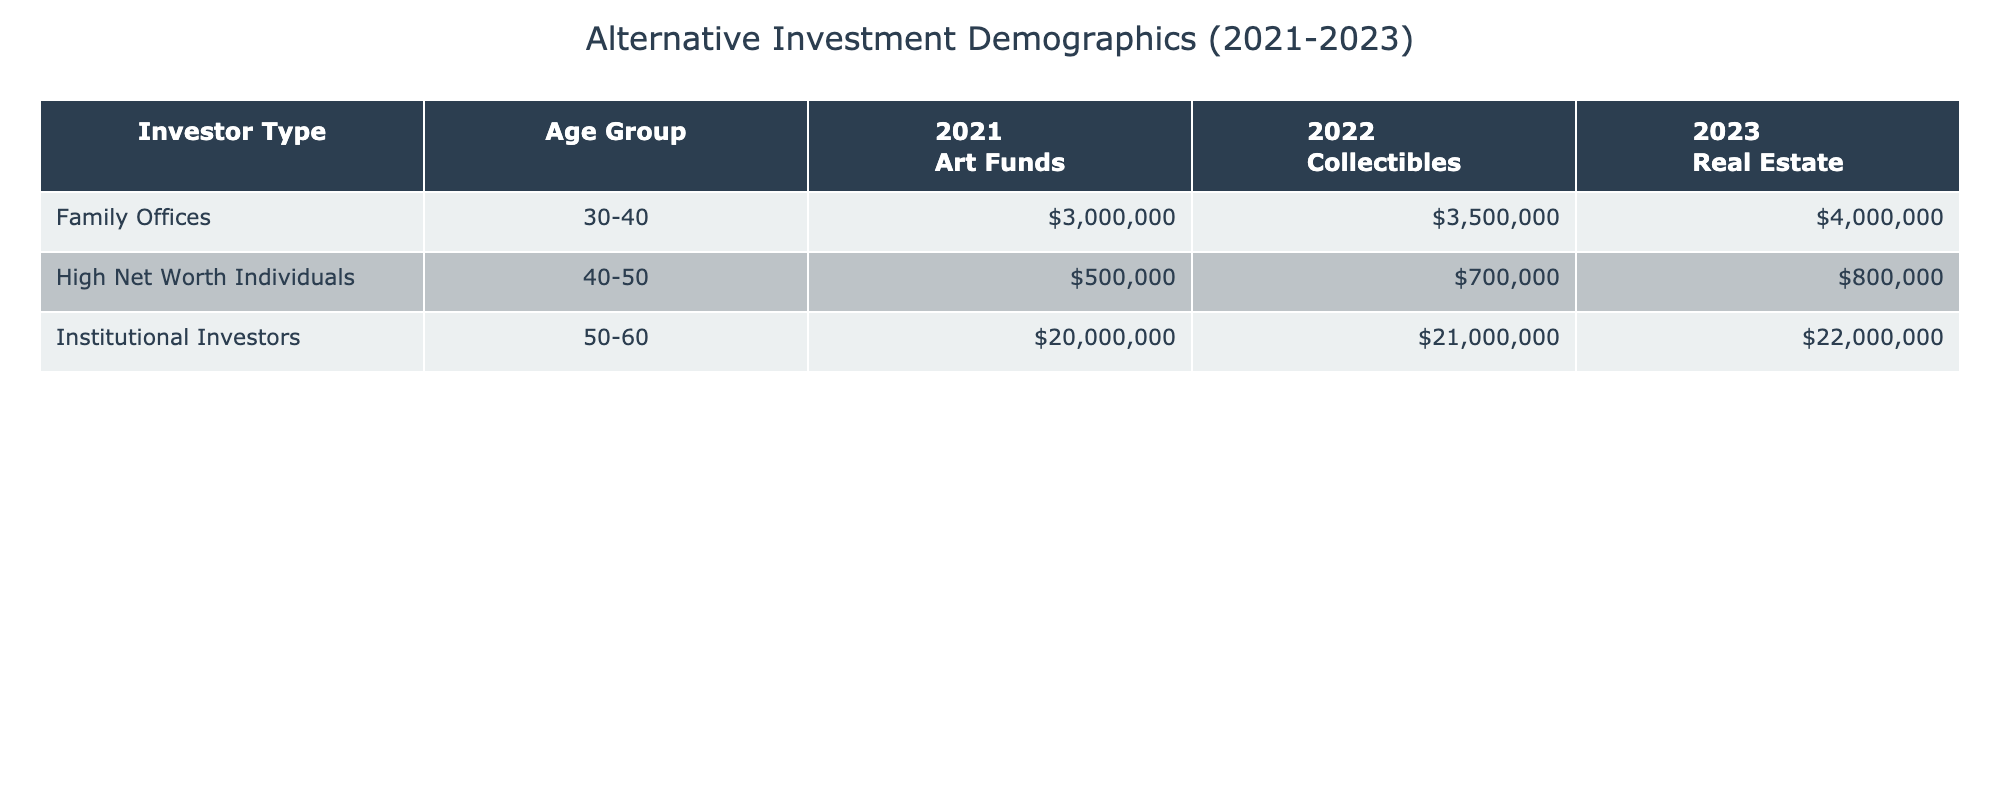What was the average investment of High Net Worth Individuals in Art Funds in 2021? The table shows that for High Net Worth Individuals in 2021, the average investment in Art Funds was $500,000.
Answer: $500,000 Which investor type had the highest average investment in 2023? In 2023, Institutional Investors had the highest average investment at $22,000,000, while High Net Worth Individuals and Family Offices had lower amounts for their respective investments.
Answer: Institutional Investors What is the average investment for Family Offices across all three years? To find the average: In 2021, they invested $3,000,000; in 2022, $3,500,000; and in 2023, $4,000,000. The total is $3,000,000 + $3,500,000 + $4,000,000 = $10,500,000. Dividing by 3 gives an average of $3,500,000.
Answer: $3,500,000 Did High Net Worth Individuals invest in collectibles in 2021? According to the table, High Net Worth Individuals did not invest in collectibles in 2021, as their recorded investment was in Art Funds.
Answer: No Which year saw a consistent increase in average investment for Institutional Investors from Art Funds to Real Estate? The averages for Institutional Investors in Art Funds in 2021, Collectibles in 2022, and Real Estate in 2023 are $20,000,000, $21,000,000, and $22,000,000 respectively, showing a consistent increase year over year.
Answer: Yes What was the average investment for the age group 40-50 across all investor types in 2022? High Net Worth Individuals invested $700,000 and Institutional Investors invested $21,000,000. There are two data points, and adding these: $700,000 + $21,000,000 = $21,700,000. Dividing by 2 gives an average of $10,850,000.
Answer: $10,850,000 Which investment title had the highest average amount for Family Offices over the three years? Family Offices consistently invested $3,000,000 in Art Funds in 2021, $3,500,000 in Collectibles in 2022, and $4,000,000 in Real Estate in 2023. The highest is $4,000,000 in Real Estate.
Answer: Real Estate How much more did Institutional Investors invest in Real Estate compared to Art Funds in 2023? The average investment in Real Estate by Institutional Investors in 2023 was $22,000,000, while it was $20,000,000 in Art Funds in 2021. The difference is $22,000,000 - $20,000,000 = $2,000,000.
Answer: $2,000,000 